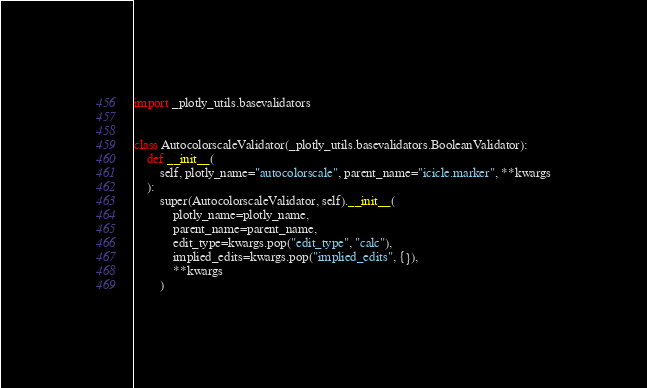Convert code to text. <code><loc_0><loc_0><loc_500><loc_500><_Python_>import _plotly_utils.basevalidators


class AutocolorscaleValidator(_plotly_utils.basevalidators.BooleanValidator):
    def __init__(
        self, plotly_name="autocolorscale", parent_name="icicle.marker", **kwargs
    ):
        super(AutocolorscaleValidator, self).__init__(
            plotly_name=plotly_name,
            parent_name=parent_name,
            edit_type=kwargs.pop("edit_type", "calc"),
            implied_edits=kwargs.pop("implied_edits", {}),
            **kwargs
        )
</code> 